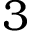Convert formula to latex. <formula><loc_0><loc_0><loc_500><loc_500>3</formula> 